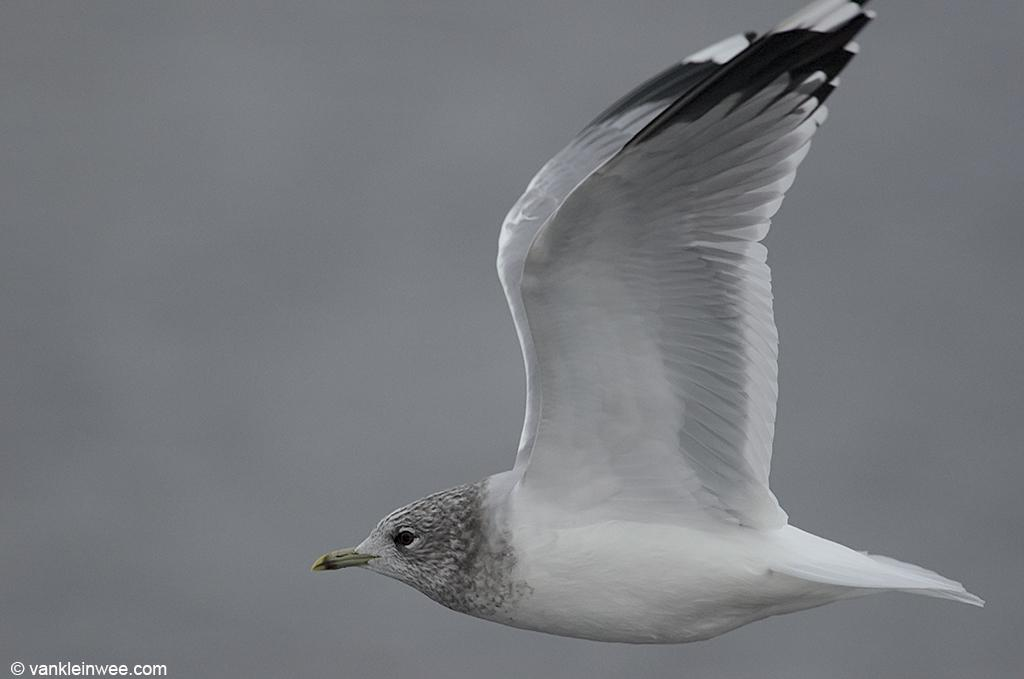What is the color scheme of the image? The image is black and white. What can be seen in the air in the image? There is a bird flying in the air. How would you describe the background of the image? The background is blurred. Is there any additional information or branding on the image? Yes, there is a watermark on the image. What type of action is the fireman performing in the image? There is no fireman present in the image, so no action involving a fireman can be observed. 